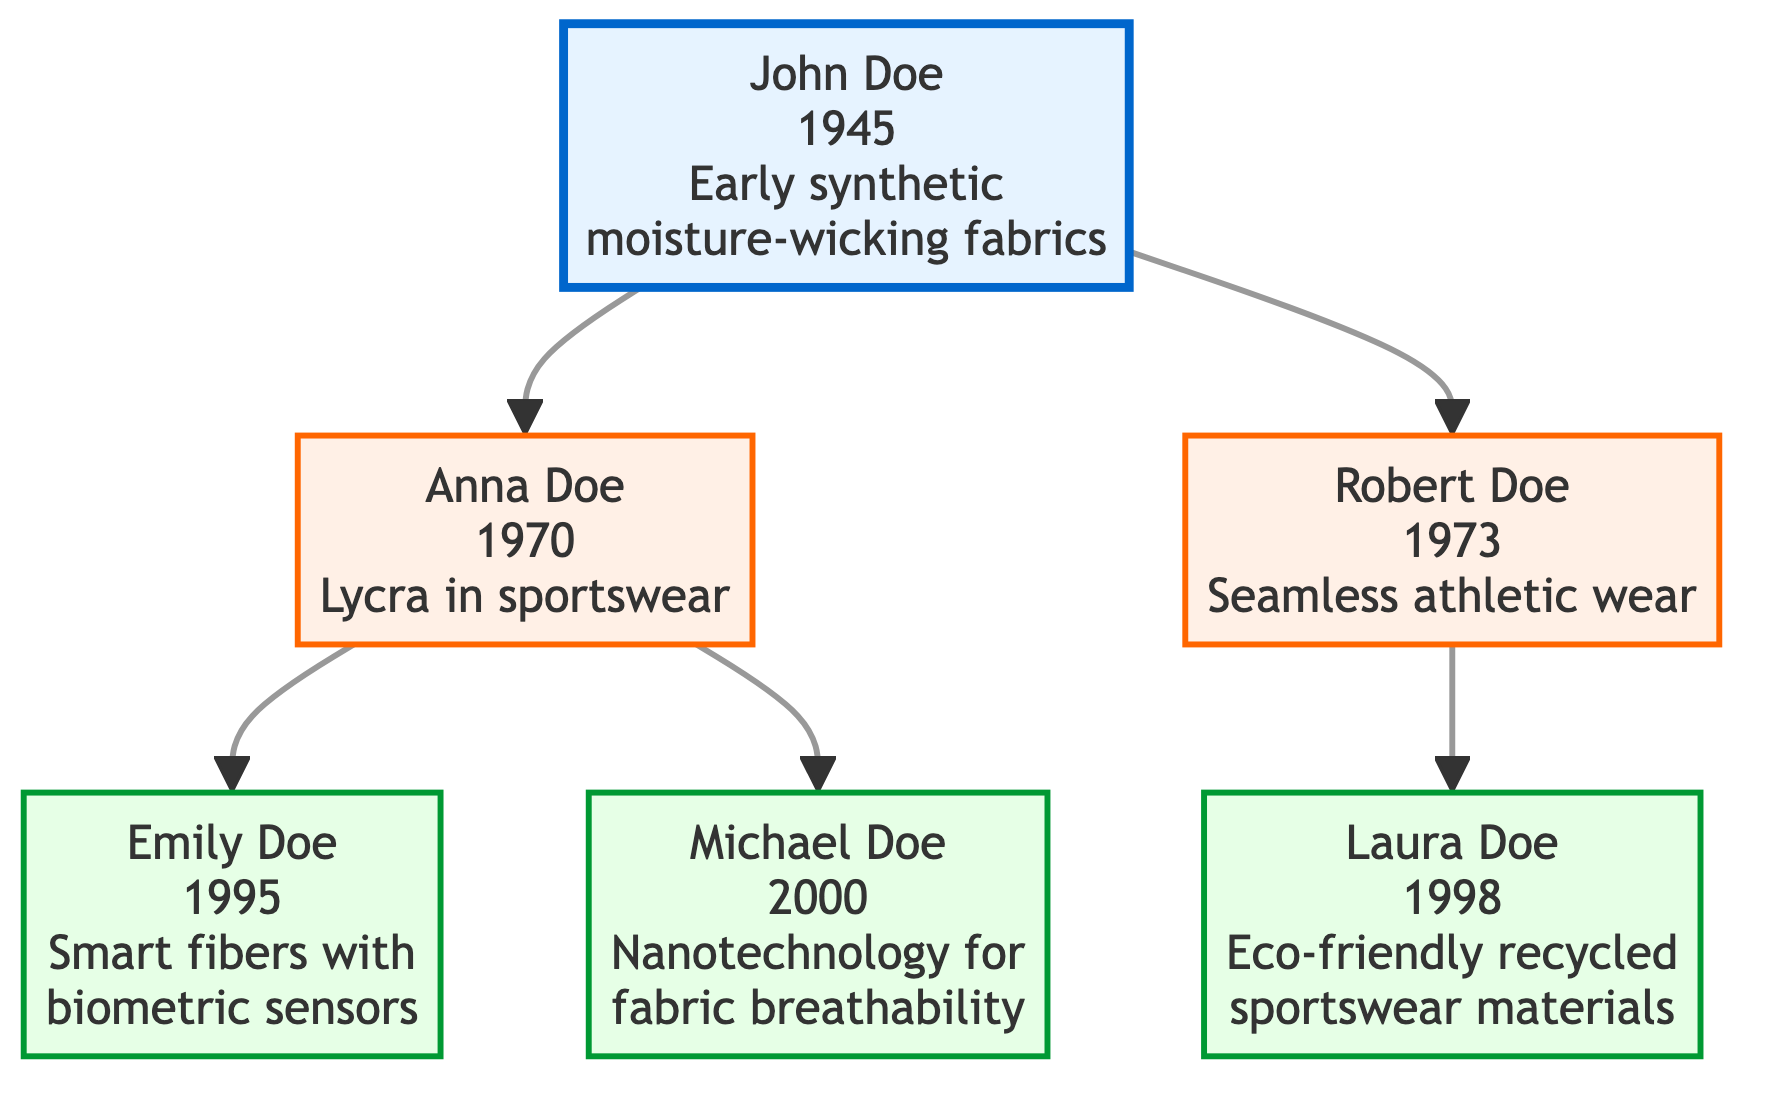What year was John Doe born? The diagram shows that John Doe, the founder of the family tree, was born in 1945. This information is directly stated in the node for John Doe.
Answer: 1945 Who is the child of Robert Doe? In the diagram, Robert Doe has one child, Laura Doe. The relationship is depicted with a direct connection from Robert Doe to Laura Doe.
Answer: Laura Doe What significant contribution did Emily Doe make? The node for Emily Doe indicates her contribution was integrating smart fibers with biometric sensors. This is a descriptive aspect found in her specific node.
Answer: Integrated smart fibers with biometric sensors Which generation is Anna Doe? Anna Doe is one of the children of John Doe, placing her in the second generation. This generational information can be deduced from the family tree structure where she is directly linked below John Doe.
Answer: Second How many children does Robert Doe have? The diagram shows that Robert Doe has one child, which is Laura Doe. The node for Robert Doe connects only to one child, indicating a total of one child.
Answer: One Which innovation did Michael Doe focus on? In the diagram, Michael Doe's contribution is noted as enhanced fabric breathability through nanotechnology. This information is clearly specified in his node.
Answer: Enhanced fabric breathability through nanotechnology Which family member was born in 1998? According to the diagram, Laura Doe was born in 1998. This information can be directly retrieved from the birth year associated with her node.
Answer: Laura Doe What are the contributions of the second generation? The contributions of the second generation, represented by Anna Doe and Robert Doe, include pioneering Lycra in sportswear and designing seamless athletic wear for improved comfort, respectively. Analyzing the nodes of the second generation gives this information by combining their contributions.
Answer: Lycra in sportswear, Seamless athletic wear Who contributed to eco-friendly materials for sportswear? The diagram shows Laura Doe developed eco-friendly recycled materials for sportswear. This is clearly indicated in the explanation associated with her node.
Answer: Developed eco-friendly recycled materials for sportswear 